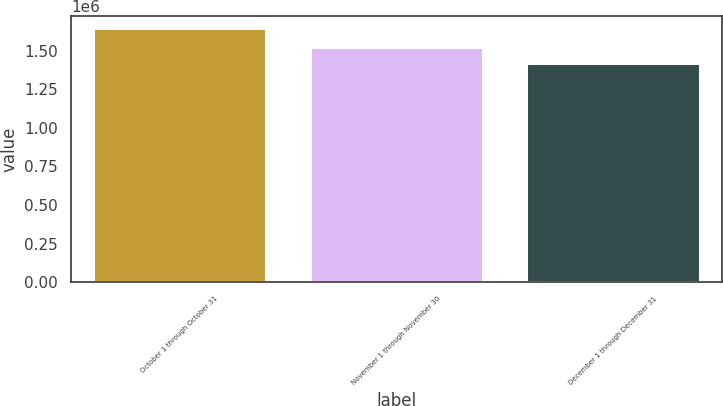Convert chart. <chart><loc_0><loc_0><loc_500><loc_500><bar_chart><fcel>October 1 through October 31<fcel>November 1 through November 30<fcel>December 1 through December 31<nl><fcel>1.64429e+06<fcel>1.52462e+06<fcel>1.42306e+06<nl></chart> 